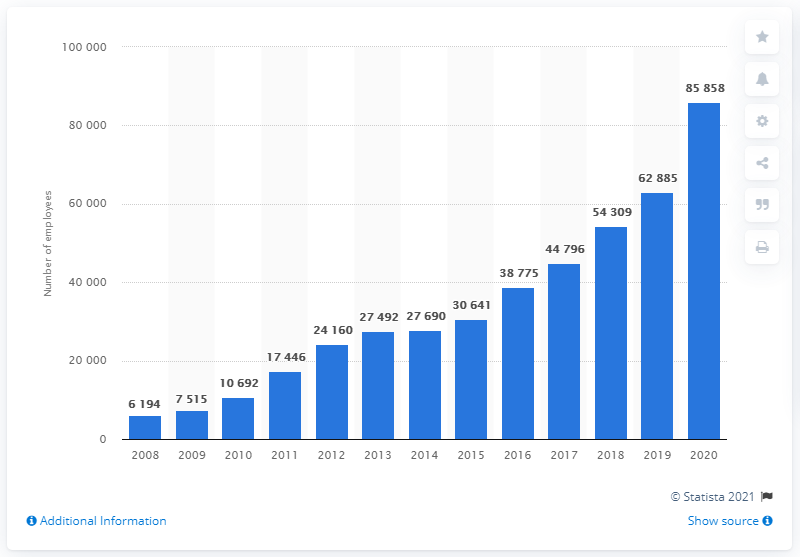List a handful of essential elements in this visual. As of December 2020, Tencent had a total of 85,858 employees. 